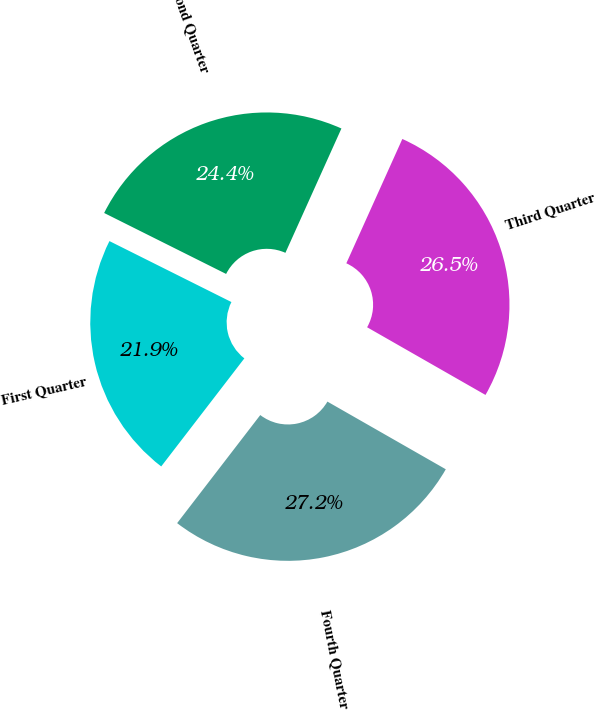Convert chart to OTSL. <chart><loc_0><loc_0><loc_500><loc_500><pie_chart><fcel>Fourth Quarter<fcel>Third Quarter<fcel>Second Quarter<fcel>First Quarter<nl><fcel>27.17%<fcel>26.53%<fcel>24.36%<fcel>21.94%<nl></chart> 